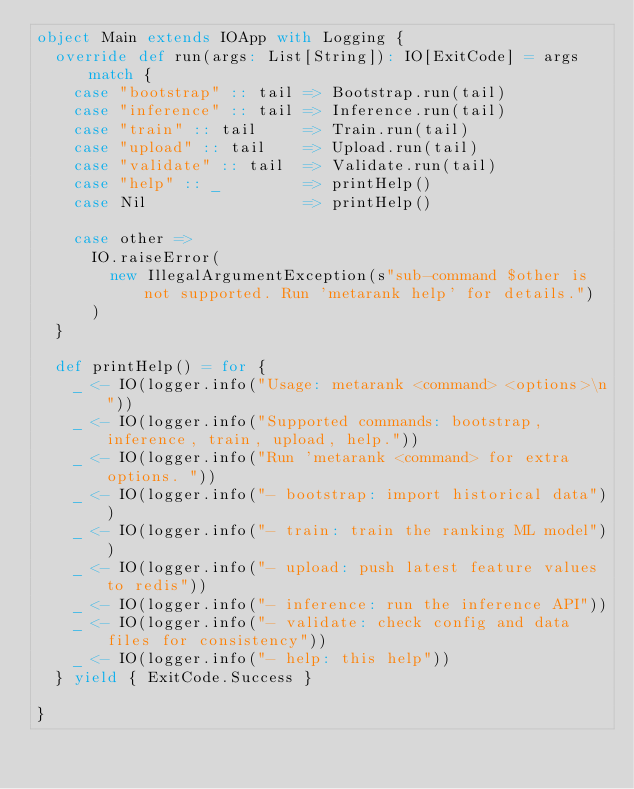<code> <loc_0><loc_0><loc_500><loc_500><_Scala_>object Main extends IOApp with Logging {
  override def run(args: List[String]): IO[ExitCode] = args match {
    case "bootstrap" :: tail => Bootstrap.run(tail)
    case "inference" :: tail => Inference.run(tail)
    case "train" :: tail     => Train.run(tail)
    case "upload" :: tail    => Upload.run(tail)
    case "validate" :: tail  => Validate.run(tail)
    case "help" :: _         => printHelp()
    case Nil                 => printHelp()

    case other =>
      IO.raiseError(
        new IllegalArgumentException(s"sub-command $other is not supported. Run 'metarank help' for details.")
      )
  }

  def printHelp() = for {
    _ <- IO(logger.info("Usage: metarank <command> <options>\n"))
    _ <- IO(logger.info("Supported commands: bootstrap, inference, train, upload, help."))
    _ <- IO(logger.info("Run 'metarank <command> for extra options. "))
    _ <- IO(logger.info("- bootstrap: import historical data"))
    _ <- IO(logger.info("- train: train the ranking ML model"))
    _ <- IO(logger.info("- upload: push latest feature values to redis"))
    _ <- IO(logger.info("- inference: run the inference API"))
    _ <- IO(logger.info("- validate: check config and data files for consistency"))
    _ <- IO(logger.info("- help: this help"))
  } yield { ExitCode.Success }

}
</code> 